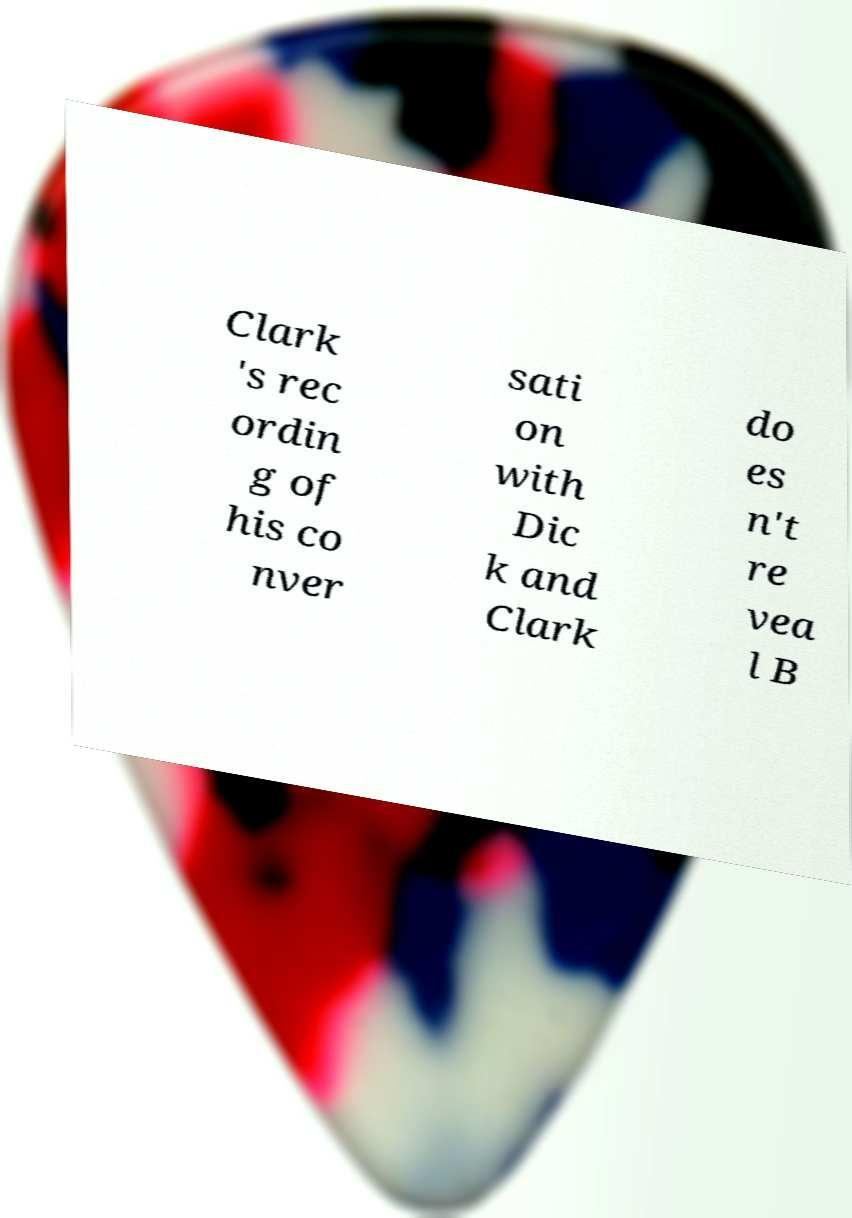I need the written content from this picture converted into text. Can you do that? Clark 's rec ordin g of his co nver sati on with Dic k and Clark do es n't re vea l B 